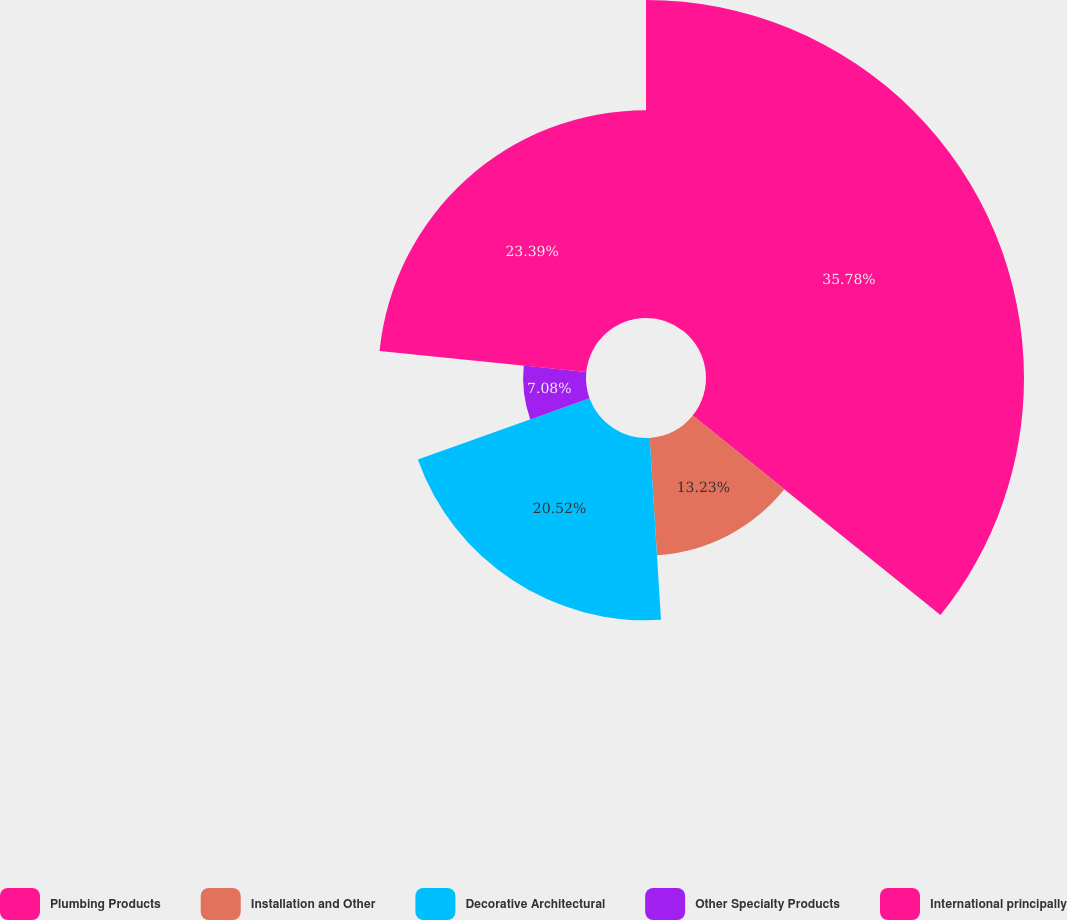<chart> <loc_0><loc_0><loc_500><loc_500><pie_chart><fcel>Plumbing Products<fcel>Installation and Other<fcel>Decorative Architectural<fcel>Other Specialty Products<fcel>International principally<nl><fcel>35.79%<fcel>13.23%<fcel>20.52%<fcel>7.08%<fcel>23.39%<nl></chart> 